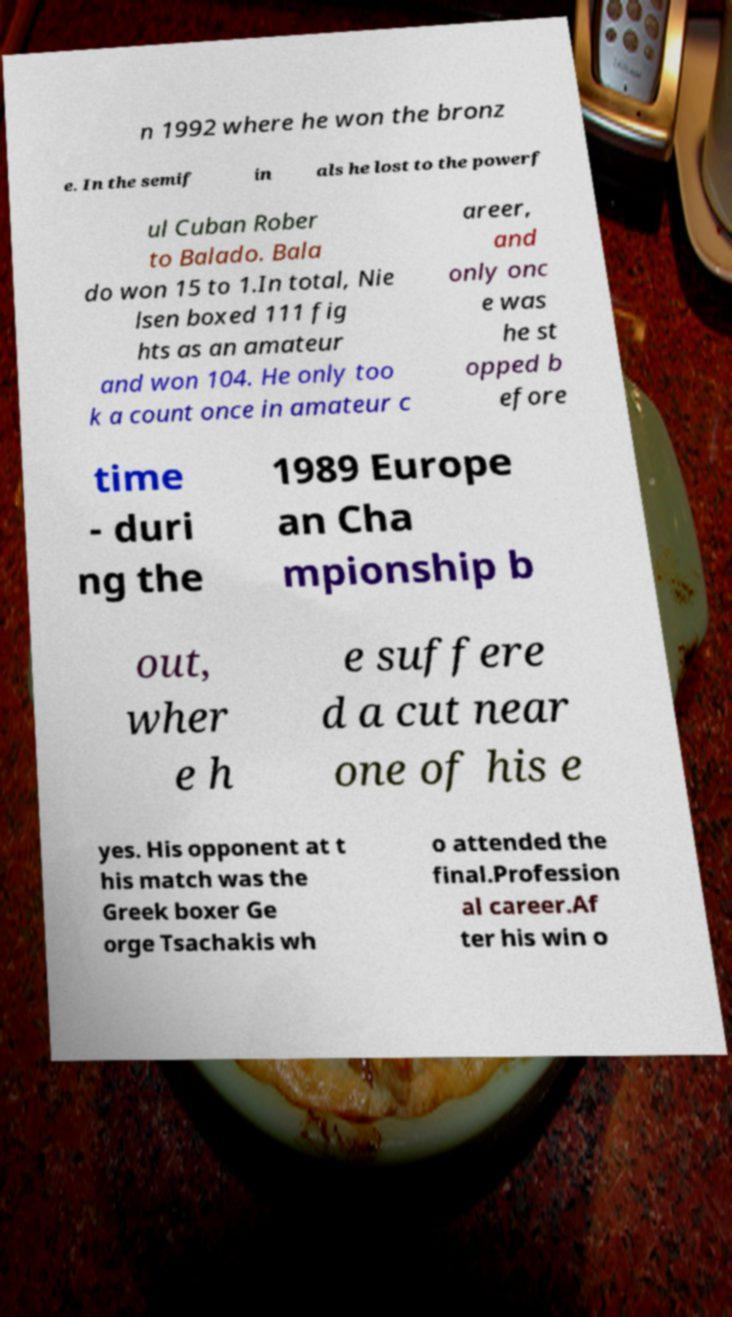For documentation purposes, I need the text within this image transcribed. Could you provide that? n 1992 where he won the bronz e. In the semif in als he lost to the powerf ul Cuban Rober to Balado. Bala do won 15 to 1.In total, Nie lsen boxed 111 fig hts as an amateur and won 104. He only too k a count once in amateur c areer, and only onc e was he st opped b efore time - duri ng the 1989 Europe an Cha mpionship b out, wher e h e suffere d a cut near one of his e yes. His opponent at t his match was the Greek boxer Ge orge Tsachakis wh o attended the final.Profession al career.Af ter his win o 